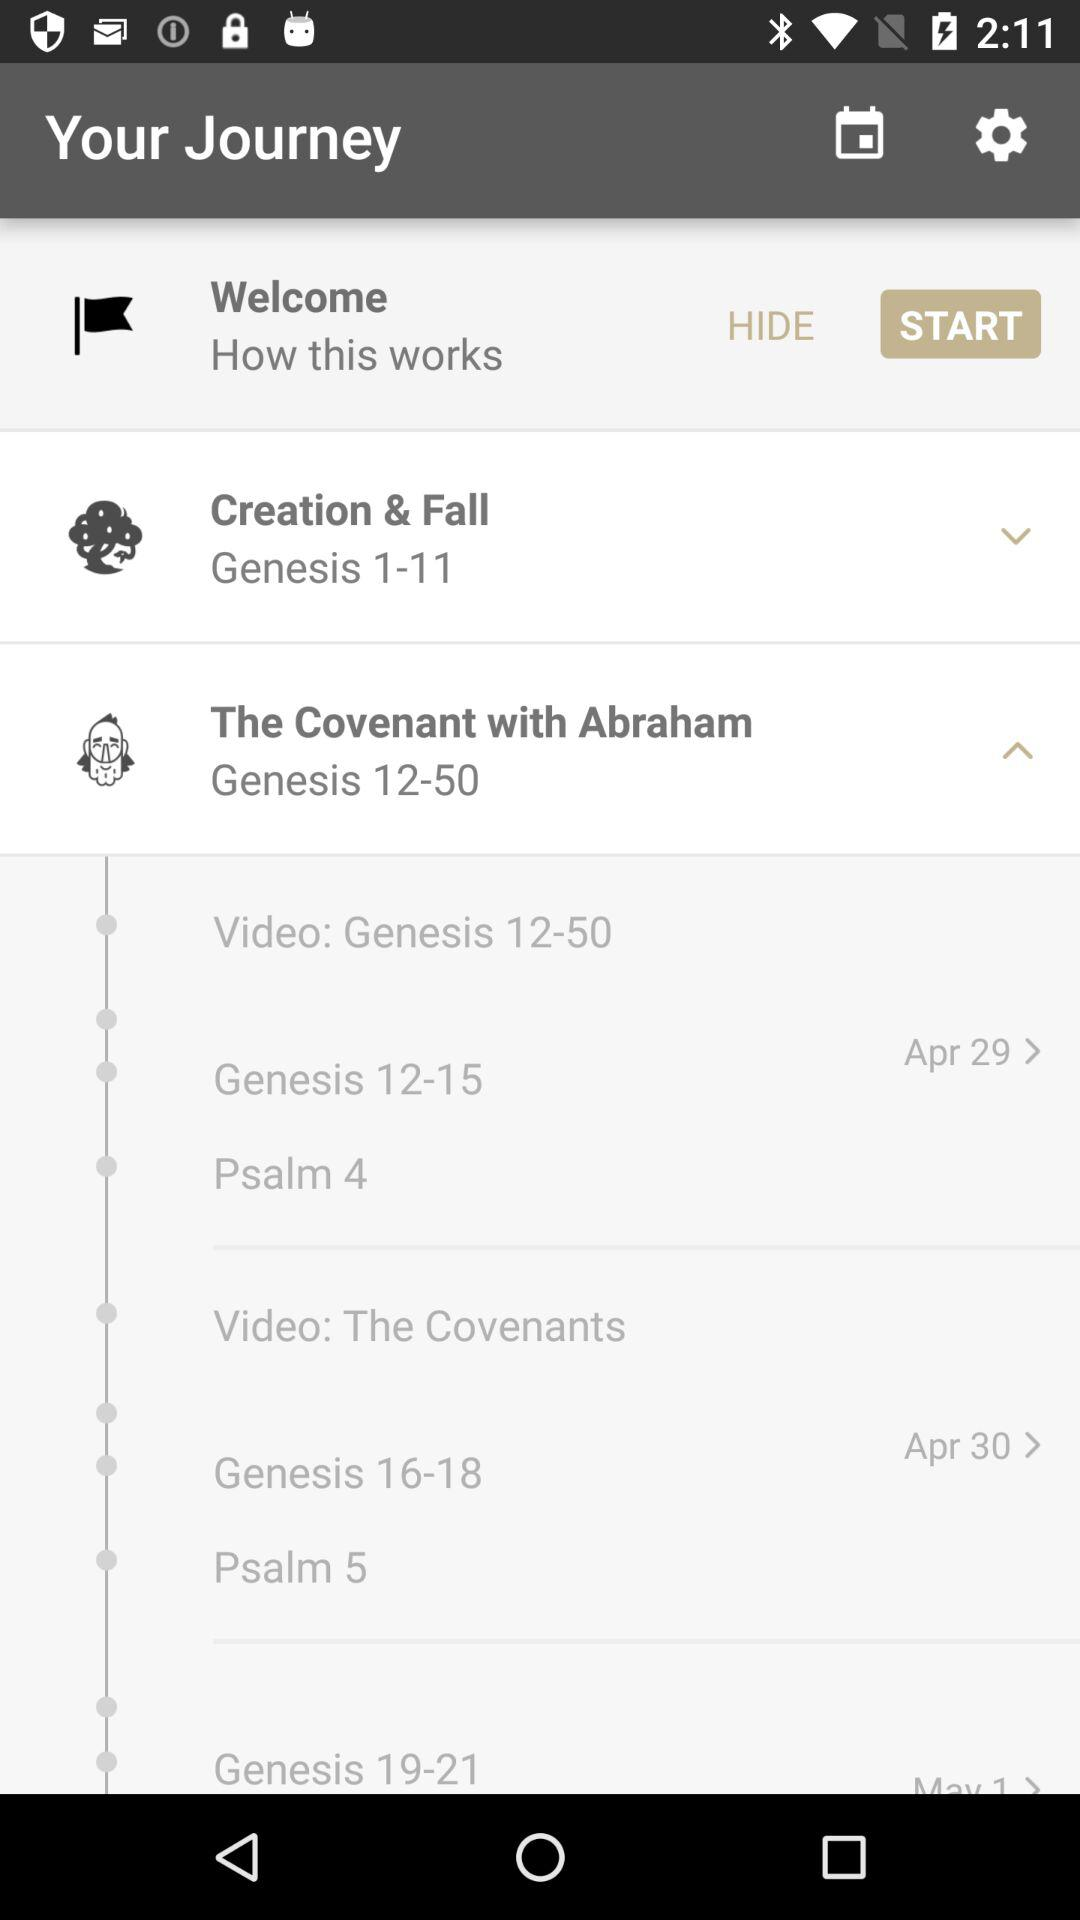What is the scheduled date for "Psalm 4"? The scheduled date is April 29. 